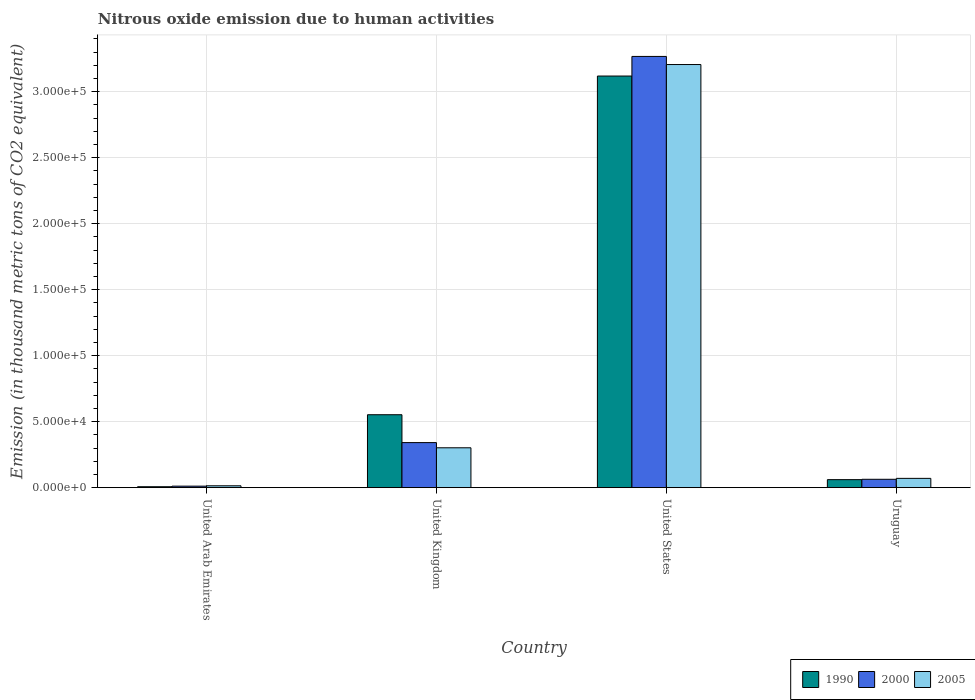How many bars are there on the 2nd tick from the left?
Your response must be concise. 3. What is the label of the 1st group of bars from the left?
Give a very brief answer. United Arab Emirates. What is the amount of nitrous oxide emitted in 2000 in Uruguay?
Your response must be concise. 6333.8. Across all countries, what is the maximum amount of nitrous oxide emitted in 2000?
Offer a terse response. 3.27e+05. Across all countries, what is the minimum amount of nitrous oxide emitted in 2005?
Ensure brevity in your answer.  1398.8. In which country was the amount of nitrous oxide emitted in 2000 minimum?
Provide a succinct answer. United Arab Emirates. What is the total amount of nitrous oxide emitted in 1990 in the graph?
Offer a very short reply. 3.74e+05. What is the difference between the amount of nitrous oxide emitted in 2005 in United Kingdom and that in Uruguay?
Provide a short and direct response. 2.32e+04. What is the difference between the amount of nitrous oxide emitted in 1990 in United States and the amount of nitrous oxide emitted in 2005 in United Arab Emirates?
Your answer should be compact. 3.10e+05. What is the average amount of nitrous oxide emitted in 1990 per country?
Make the answer very short. 9.35e+04. What is the difference between the amount of nitrous oxide emitted of/in 1990 and amount of nitrous oxide emitted of/in 2000 in United Arab Emirates?
Ensure brevity in your answer.  -431.4. What is the ratio of the amount of nitrous oxide emitted in 1990 in United Arab Emirates to that in United Kingdom?
Your response must be concise. 0.01. What is the difference between the highest and the second highest amount of nitrous oxide emitted in 2000?
Provide a succinct answer. -2.93e+05. What is the difference between the highest and the lowest amount of nitrous oxide emitted in 2000?
Make the answer very short. 3.26e+05. In how many countries, is the amount of nitrous oxide emitted in 2000 greater than the average amount of nitrous oxide emitted in 2000 taken over all countries?
Your answer should be very brief. 1. What does the 3rd bar from the right in United States represents?
Provide a succinct answer. 1990. How many bars are there?
Ensure brevity in your answer.  12. Are all the bars in the graph horizontal?
Provide a short and direct response. No. How many countries are there in the graph?
Provide a succinct answer. 4. Does the graph contain any zero values?
Provide a short and direct response. No. Does the graph contain grids?
Keep it short and to the point. Yes. How many legend labels are there?
Offer a terse response. 3. How are the legend labels stacked?
Give a very brief answer. Horizontal. What is the title of the graph?
Offer a very short reply. Nitrous oxide emission due to human activities. What is the label or title of the Y-axis?
Offer a terse response. Emission (in thousand metric tons of CO2 equivalent). What is the Emission (in thousand metric tons of CO2 equivalent) in 1990 in United Arab Emirates?
Make the answer very short. 699.1. What is the Emission (in thousand metric tons of CO2 equivalent) of 2000 in United Arab Emirates?
Make the answer very short. 1130.5. What is the Emission (in thousand metric tons of CO2 equivalent) in 2005 in United Arab Emirates?
Give a very brief answer. 1398.8. What is the Emission (in thousand metric tons of CO2 equivalent) in 1990 in United Kingdom?
Your response must be concise. 5.53e+04. What is the Emission (in thousand metric tons of CO2 equivalent) in 2000 in United Kingdom?
Your answer should be compact. 3.41e+04. What is the Emission (in thousand metric tons of CO2 equivalent) in 2005 in United Kingdom?
Make the answer very short. 3.02e+04. What is the Emission (in thousand metric tons of CO2 equivalent) in 1990 in United States?
Keep it short and to the point. 3.12e+05. What is the Emission (in thousand metric tons of CO2 equivalent) of 2000 in United States?
Your answer should be compact. 3.27e+05. What is the Emission (in thousand metric tons of CO2 equivalent) in 2005 in United States?
Your response must be concise. 3.21e+05. What is the Emission (in thousand metric tons of CO2 equivalent) in 1990 in Uruguay?
Make the answer very short. 6054.9. What is the Emission (in thousand metric tons of CO2 equivalent) of 2000 in Uruguay?
Provide a succinct answer. 6333.8. What is the Emission (in thousand metric tons of CO2 equivalent) of 2005 in Uruguay?
Provide a short and direct response. 7032.9. Across all countries, what is the maximum Emission (in thousand metric tons of CO2 equivalent) of 1990?
Your answer should be very brief. 3.12e+05. Across all countries, what is the maximum Emission (in thousand metric tons of CO2 equivalent) in 2000?
Offer a very short reply. 3.27e+05. Across all countries, what is the maximum Emission (in thousand metric tons of CO2 equivalent) in 2005?
Your response must be concise. 3.21e+05. Across all countries, what is the minimum Emission (in thousand metric tons of CO2 equivalent) of 1990?
Provide a succinct answer. 699.1. Across all countries, what is the minimum Emission (in thousand metric tons of CO2 equivalent) of 2000?
Keep it short and to the point. 1130.5. Across all countries, what is the minimum Emission (in thousand metric tons of CO2 equivalent) in 2005?
Give a very brief answer. 1398.8. What is the total Emission (in thousand metric tons of CO2 equivalent) of 1990 in the graph?
Your answer should be compact. 3.74e+05. What is the total Emission (in thousand metric tons of CO2 equivalent) in 2000 in the graph?
Offer a terse response. 3.68e+05. What is the total Emission (in thousand metric tons of CO2 equivalent) in 2005 in the graph?
Your response must be concise. 3.59e+05. What is the difference between the Emission (in thousand metric tons of CO2 equivalent) of 1990 in United Arab Emirates and that in United Kingdom?
Your response must be concise. -5.46e+04. What is the difference between the Emission (in thousand metric tons of CO2 equivalent) of 2000 in United Arab Emirates and that in United Kingdom?
Give a very brief answer. -3.30e+04. What is the difference between the Emission (in thousand metric tons of CO2 equivalent) in 2005 in United Arab Emirates and that in United Kingdom?
Ensure brevity in your answer.  -2.88e+04. What is the difference between the Emission (in thousand metric tons of CO2 equivalent) in 1990 in United Arab Emirates and that in United States?
Your answer should be very brief. -3.11e+05. What is the difference between the Emission (in thousand metric tons of CO2 equivalent) of 2000 in United Arab Emirates and that in United States?
Provide a short and direct response. -3.26e+05. What is the difference between the Emission (in thousand metric tons of CO2 equivalent) in 2005 in United Arab Emirates and that in United States?
Your answer should be compact. -3.19e+05. What is the difference between the Emission (in thousand metric tons of CO2 equivalent) in 1990 in United Arab Emirates and that in Uruguay?
Your answer should be compact. -5355.8. What is the difference between the Emission (in thousand metric tons of CO2 equivalent) in 2000 in United Arab Emirates and that in Uruguay?
Make the answer very short. -5203.3. What is the difference between the Emission (in thousand metric tons of CO2 equivalent) of 2005 in United Arab Emirates and that in Uruguay?
Offer a terse response. -5634.1. What is the difference between the Emission (in thousand metric tons of CO2 equivalent) in 1990 in United Kingdom and that in United States?
Offer a very short reply. -2.57e+05. What is the difference between the Emission (in thousand metric tons of CO2 equivalent) of 2000 in United Kingdom and that in United States?
Offer a terse response. -2.93e+05. What is the difference between the Emission (in thousand metric tons of CO2 equivalent) of 2005 in United Kingdom and that in United States?
Your answer should be compact. -2.90e+05. What is the difference between the Emission (in thousand metric tons of CO2 equivalent) of 1990 in United Kingdom and that in Uruguay?
Provide a short and direct response. 4.92e+04. What is the difference between the Emission (in thousand metric tons of CO2 equivalent) of 2000 in United Kingdom and that in Uruguay?
Offer a very short reply. 2.78e+04. What is the difference between the Emission (in thousand metric tons of CO2 equivalent) of 2005 in United Kingdom and that in Uruguay?
Your answer should be very brief. 2.32e+04. What is the difference between the Emission (in thousand metric tons of CO2 equivalent) of 1990 in United States and that in Uruguay?
Make the answer very short. 3.06e+05. What is the difference between the Emission (in thousand metric tons of CO2 equivalent) of 2000 in United States and that in Uruguay?
Your response must be concise. 3.20e+05. What is the difference between the Emission (in thousand metric tons of CO2 equivalent) of 2005 in United States and that in Uruguay?
Give a very brief answer. 3.14e+05. What is the difference between the Emission (in thousand metric tons of CO2 equivalent) in 1990 in United Arab Emirates and the Emission (in thousand metric tons of CO2 equivalent) in 2000 in United Kingdom?
Your answer should be very brief. -3.34e+04. What is the difference between the Emission (in thousand metric tons of CO2 equivalent) of 1990 in United Arab Emirates and the Emission (in thousand metric tons of CO2 equivalent) of 2005 in United Kingdom?
Provide a short and direct response. -2.95e+04. What is the difference between the Emission (in thousand metric tons of CO2 equivalent) in 2000 in United Arab Emirates and the Emission (in thousand metric tons of CO2 equivalent) in 2005 in United Kingdom?
Your answer should be compact. -2.91e+04. What is the difference between the Emission (in thousand metric tons of CO2 equivalent) in 1990 in United Arab Emirates and the Emission (in thousand metric tons of CO2 equivalent) in 2000 in United States?
Keep it short and to the point. -3.26e+05. What is the difference between the Emission (in thousand metric tons of CO2 equivalent) of 1990 in United Arab Emirates and the Emission (in thousand metric tons of CO2 equivalent) of 2005 in United States?
Your response must be concise. -3.20e+05. What is the difference between the Emission (in thousand metric tons of CO2 equivalent) of 2000 in United Arab Emirates and the Emission (in thousand metric tons of CO2 equivalent) of 2005 in United States?
Give a very brief answer. -3.19e+05. What is the difference between the Emission (in thousand metric tons of CO2 equivalent) of 1990 in United Arab Emirates and the Emission (in thousand metric tons of CO2 equivalent) of 2000 in Uruguay?
Keep it short and to the point. -5634.7. What is the difference between the Emission (in thousand metric tons of CO2 equivalent) in 1990 in United Arab Emirates and the Emission (in thousand metric tons of CO2 equivalent) in 2005 in Uruguay?
Make the answer very short. -6333.8. What is the difference between the Emission (in thousand metric tons of CO2 equivalent) of 2000 in United Arab Emirates and the Emission (in thousand metric tons of CO2 equivalent) of 2005 in Uruguay?
Your answer should be very brief. -5902.4. What is the difference between the Emission (in thousand metric tons of CO2 equivalent) of 1990 in United Kingdom and the Emission (in thousand metric tons of CO2 equivalent) of 2000 in United States?
Keep it short and to the point. -2.71e+05. What is the difference between the Emission (in thousand metric tons of CO2 equivalent) of 1990 in United Kingdom and the Emission (in thousand metric tons of CO2 equivalent) of 2005 in United States?
Offer a very short reply. -2.65e+05. What is the difference between the Emission (in thousand metric tons of CO2 equivalent) in 2000 in United Kingdom and the Emission (in thousand metric tons of CO2 equivalent) in 2005 in United States?
Your answer should be very brief. -2.86e+05. What is the difference between the Emission (in thousand metric tons of CO2 equivalent) of 1990 in United Kingdom and the Emission (in thousand metric tons of CO2 equivalent) of 2000 in Uruguay?
Offer a very short reply. 4.89e+04. What is the difference between the Emission (in thousand metric tons of CO2 equivalent) in 1990 in United Kingdom and the Emission (in thousand metric tons of CO2 equivalent) in 2005 in Uruguay?
Your response must be concise. 4.82e+04. What is the difference between the Emission (in thousand metric tons of CO2 equivalent) in 2000 in United Kingdom and the Emission (in thousand metric tons of CO2 equivalent) in 2005 in Uruguay?
Keep it short and to the point. 2.71e+04. What is the difference between the Emission (in thousand metric tons of CO2 equivalent) of 1990 in United States and the Emission (in thousand metric tons of CO2 equivalent) of 2000 in Uruguay?
Provide a short and direct response. 3.06e+05. What is the difference between the Emission (in thousand metric tons of CO2 equivalent) of 1990 in United States and the Emission (in thousand metric tons of CO2 equivalent) of 2005 in Uruguay?
Your answer should be compact. 3.05e+05. What is the difference between the Emission (in thousand metric tons of CO2 equivalent) of 2000 in United States and the Emission (in thousand metric tons of CO2 equivalent) of 2005 in Uruguay?
Provide a short and direct response. 3.20e+05. What is the average Emission (in thousand metric tons of CO2 equivalent) in 1990 per country?
Your response must be concise. 9.35e+04. What is the average Emission (in thousand metric tons of CO2 equivalent) of 2000 per country?
Give a very brief answer. 9.21e+04. What is the average Emission (in thousand metric tons of CO2 equivalent) in 2005 per country?
Give a very brief answer. 8.98e+04. What is the difference between the Emission (in thousand metric tons of CO2 equivalent) in 1990 and Emission (in thousand metric tons of CO2 equivalent) in 2000 in United Arab Emirates?
Offer a very short reply. -431.4. What is the difference between the Emission (in thousand metric tons of CO2 equivalent) in 1990 and Emission (in thousand metric tons of CO2 equivalent) in 2005 in United Arab Emirates?
Your answer should be very brief. -699.7. What is the difference between the Emission (in thousand metric tons of CO2 equivalent) in 2000 and Emission (in thousand metric tons of CO2 equivalent) in 2005 in United Arab Emirates?
Keep it short and to the point. -268.3. What is the difference between the Emission (in thousand metric tons of CO2 equivalent) of 1990 and Emission (in thousand metric tons of CO2 equivalent) of 2000 in United Kingdom?
Your answer should be compact. 2.11e+04. What is the difference between the Emission (in thousand metric tons of CO2 equivalent) in 1990 and Emission (in thousand metric tons of CO2 equivalent) in 2005 in United Kingdom?
Give a very brief answer. 2.51e+04. What is the difference between the Emission (in thousand metric tons of CO2 equivalent) in 2000 and Emission (in thousand metric tons of CO2 equivalent) in 2005 in United Kingdom?
Provide a short and direct response. 3932.5. What is the difference between the Emission (in thousand metric tons of CO2 equivalent) of 1990 and Emission (in thousand metric tons of CO2 equivalent) of 2000 in United States?
Ensure brevity in your answer.  -1.49e+04. What is the difference between the Emission (in thousand metric tons of CO2 equivalent) of 1990 and Emission (in thousand metric tons of CO2 equivalent) of 2005 in United States?
Ensure brevity in your answer.  -8707.9. What is the difference between the Emission (in thousand metric tons of CO2 equivalent) in 2000 and Emission (in thousand metric tons of CO2 equivalent) in 2005 in United States?
Your answer should be very brief. 6144.9. What is the difference between the Emission (in thousand metric tons of CO2 equivalent) of 1990 and Emission (in thousand metric tons of CO2 equivalent) of 2000 in Uruguay?
Offer a very short reply. -278.9. What is the difference between the Emission (in thousand metric tons of CO2 equivalent) of 1990 and Emission (in thousand metric tons of CO2 equivalent) of 2005 in Uruguay?
Ensure brevity in your answer.  -978. What is the difference between the Emission (in thousand metric tons of CO2 equivalent) in 2000 and Emission (in thousand metric tons of CO2 equivalent) in 2005 in Uruguay?
Your answer should be very brief. -699.1. What is the ratio of the Emission (in thousand metric tons of CO2 equivalent) in 1990 in United Arab Emirates to that in United Kingdom?
Your answer should be very brief. 0.01. What is the ratio of the Emission (in thousand metric tons of CO2 equivalent) in 2000 in United Arab Emirates to that in United Kingdom?
Your answer should be compact. 0.03. What is the ratio of the Emission (in thousand metric tons of CO2 equivalent) of 2005 in United Arab Emirates to that in United Kingdom?
Make the answer very short. 0.05. What is the ratio of the Emission (in thousand metric tons of CO2 equivalent) of 1990 in United Arab Emirates to that in United States?
Provide a succinct answer. 0. What is the ratio of the Emission (in thousand metric tons of CO2 equivalent) of 2000 in United Arab Emirates to that in United States?
Make the answer very short. 0. What is the ratio of the Emission (in thousand metric tons of CO2 equivalent) in 2005 in United Arab Emirates to that in United States?
Your answer should be very brief. 0. What is the ratio of the Emission (in thousand metric tons of CO2 equivalent) in 1990 in United Arab Emirates to that in Uruguay?
Your answer should be very brief. 0.12. What is the ratio of the Emission (in thousand metric tons of CO2 equivalent) in 2000 in United Arab Emirates to that in Uruguay?
Provide a succinct answer. 0.18. What is the ratio of the Emission (in thousand metric tons of CO2 equivalent) of 2005 in United Arab Emirates to that in Uruguay?
Make the answer very short. 0.2. What is the ratio of the Emission (in thousand metric tons of CO2 equivalent) of 1990 in United Kingdom to that in United States?
Make the answer very short. 0.18. What is the ratio of the Emission (in thousand metric tons of CO2 equivalent) in 2000 in United Kingdom to that in United States?
Your answer should be very brief. 0.1. What is the ratio of the Emission (in thousand metric tons of CO2 equivalent) of 2005 in United Kingdom to that in United States?
Ensure brevity in your answer.  0.09. What is the ratio of the Emission (in thousand metric tons of CO2 equivalent) in 1990 in United Kingdom to that in Uruguay?
Ensure brevity in your answer.  9.12. What is the ratio of the Emission (in thousand metric tons of CO2 equivalent) of 2000 in United Kingdom to that in Uruguay?
Give a very brief answer. 5.39. What is the ratio of the Emission (in thousand metric tons of CO2 equivalent) of 2005 in United Kingdom to that in Uruguay?
Provide a succinct answer. 4.29. What is the ratio of the Emission (in thousand metric tons of CO2 equivalent) in 1990 in United States to that in Uruguay?
Your answer should be very brief. 51.51. What is the ratio of the Emission (in thousand metric tons of CO2 equivalent) in 2000 in United States to that in Uruguay?
Offer a terse response. 51.59. What is the ratio of the Emission (in thousand metric tons of CO2 equivalent) of 2005 in United States to that in Uruguay?
Give a very brief answer. 45.59. What is the difference between the highest and the second highest Emission (in thousand metric tons of CO2 equivalent) of 1990?
Ensure brevity in your answer.  2.57e+05. What is the difference between the highest and the second highest Emission (in thousand metric tons of CO2 equivalent) in 2000?
Offer a terse response. 2.93e+05. What is the difference between the highest and the second highest Emission (in thousand metric tons of CO2 equivalent) in 2005?
Give a very brief answer. 2.90e+05. What is the difference between the highest and the lowest Emission (in thousand metric tons of CO2 equivalent) of 1990?
Give a very brief answer. 3.11e+05. What is the difference between the highest and the lowest Emission (in thousand metric tons of CO2 equivalent) of 2000?
Your answer should be very brief. 3.26e+05. What is the difference between the highest and the lowest Emission (in thousand metric tons of CO2 equivalent) of 2005?
Offer a very short reply. 3.19e+05. 